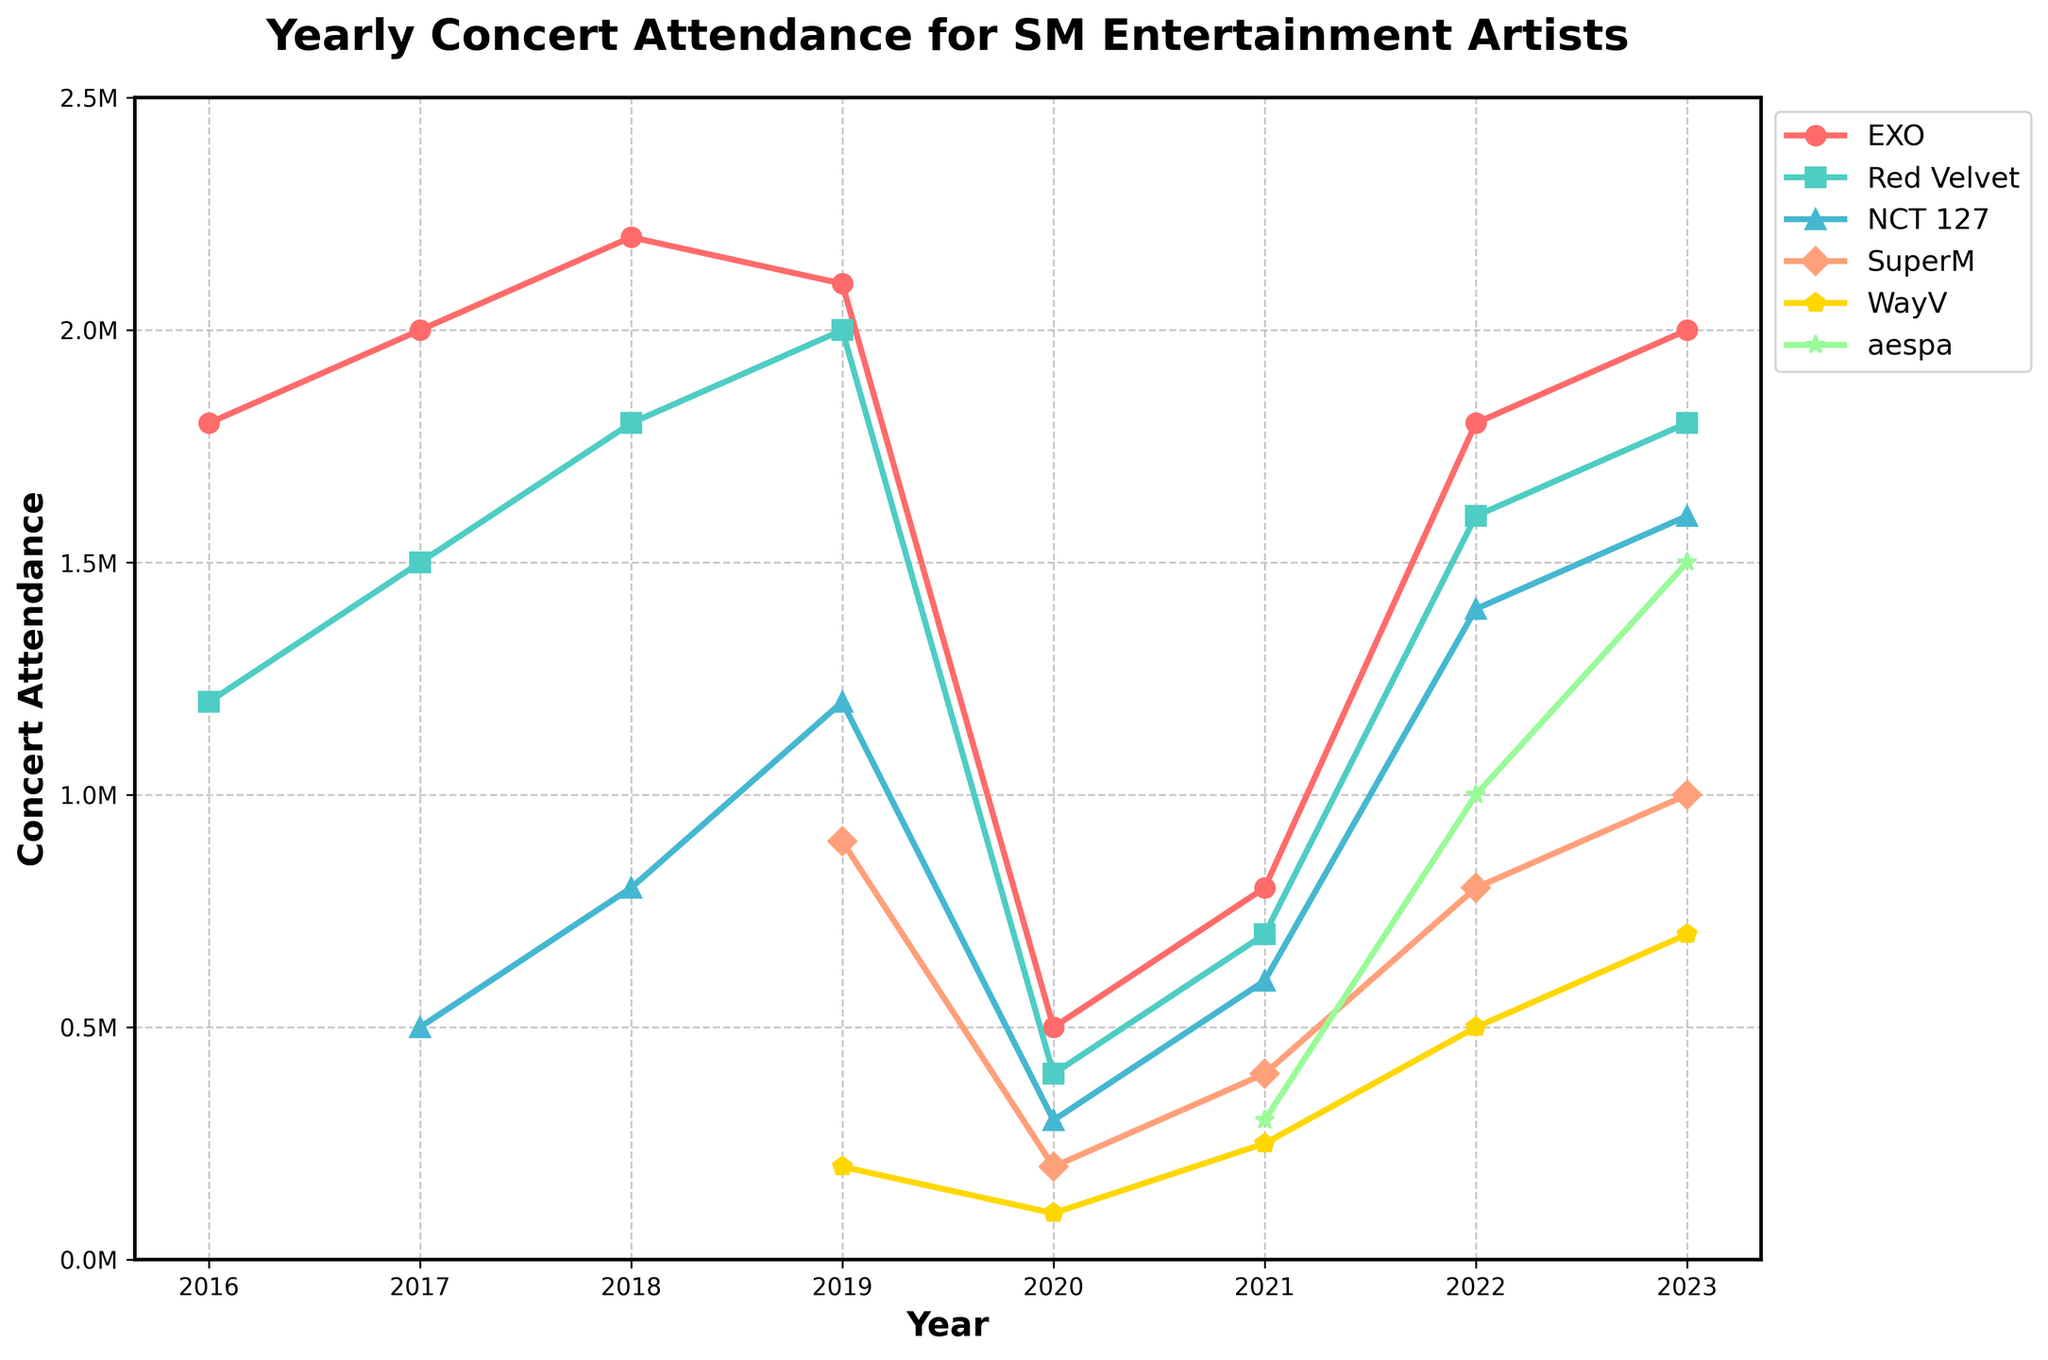Which group had the highest concert attendance in 2019? To find the group with the highest concert attendance in 2019, look at the values for each group in the year 2019. EXO had 2100000, Red Velvet had 2000000, NCT 127 had 1200000, SuperM had 900000, and WayV had 200000.
Answer: EXO Between 2020 and 2022, by how much did WayV's concert attendance increase? In 2020, WayV's attendance was 100000, and in 2022, it was 500000. The increase is 500000 - 100000 = 400000.
Answer: 400000 In which year did aespa first appear on the chart, and what was their concert attendance that year? The first appearance of aespa is in the year 2021 with an attendance of 300000.
Answer: 2021, 300000 How does WayV’s 2023 concert attendance compare to SuperM’s in the same year? In 2023, WayV's attendance was 700000, while SuperM's was 1000000. Comparing the two, WayV had a lower attendance.
Answer: Lower What is the percentage increase in NCT 127's attendance from 2017 to 2023? NCT 127's attendance in 2017 was 500000, and in 2023 it was 1600000. The increase is 1600000 - 500000 = 1100000. To find the percentage increase: (1100000 / 500000) * 100 = 220%.
Answer: 220% How does the trend of Red Velvet's concert attendance from 2016 to 2023 compare visually to that of WayV? Red Velvet's attendance shows a rise to 2019, a dip in 2020, and a recovery to high numbers by 2023. WayV starts in 2019 with lower numbers and shows a steady increase each subsequent year.
Answer: Red Velvet has greater fluctuations, while WayV has a steady increase Which group had the largest drop in concert attendance between 2019 and 2020, and what was the drop? To find the largest drop, look at the values in 2019 and 2020 for each group. EXO went from 2100000 to 500000 (drop of 1600000), Red Velvet dropped from 2000000 to 400000 (1600000), NCT 127 from 1200000 to 300000 (900000), SuperM from 900000 to 200000 (700000), and WayV from 200000 to 100000 (100000). EXO and Red Velvet both had the largest drop of 1600000.
Answer: EXO and Red Velvet, 1600000 What was the total concert attendance for all groups combined in 2022? Add up the concert attendance numbers for all groups for the year 2022. EXO: 1800000, Red Velvet: 1600000, NCT 127: 1400000, SuperM: 800000, WayV: 500000, aespa: 1000000. Total = 7100000.
Answer: 7100000 